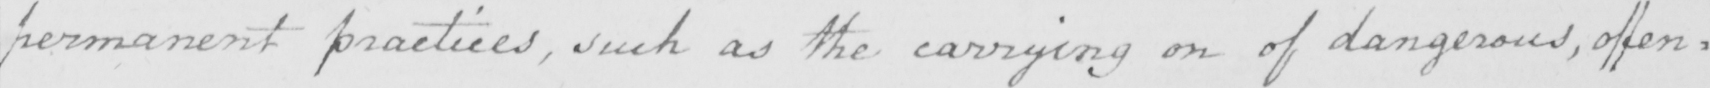Can you tell me what this handwritten text says? permanent practices , such as the carrying on of dangerous , offen= 